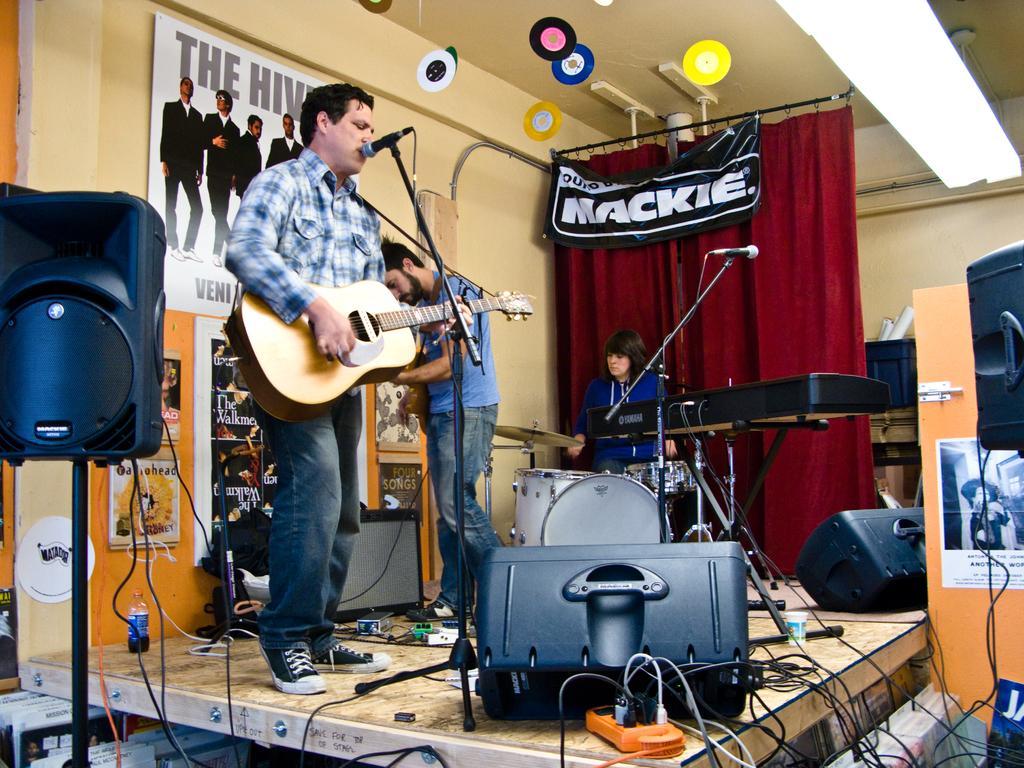How would you summarize this image in a sentence or two? This is a picture of a person who is standing on the stage holding a guitar and playing it in front mike and other two people playing some other musical instruments and there is also a speaker. 